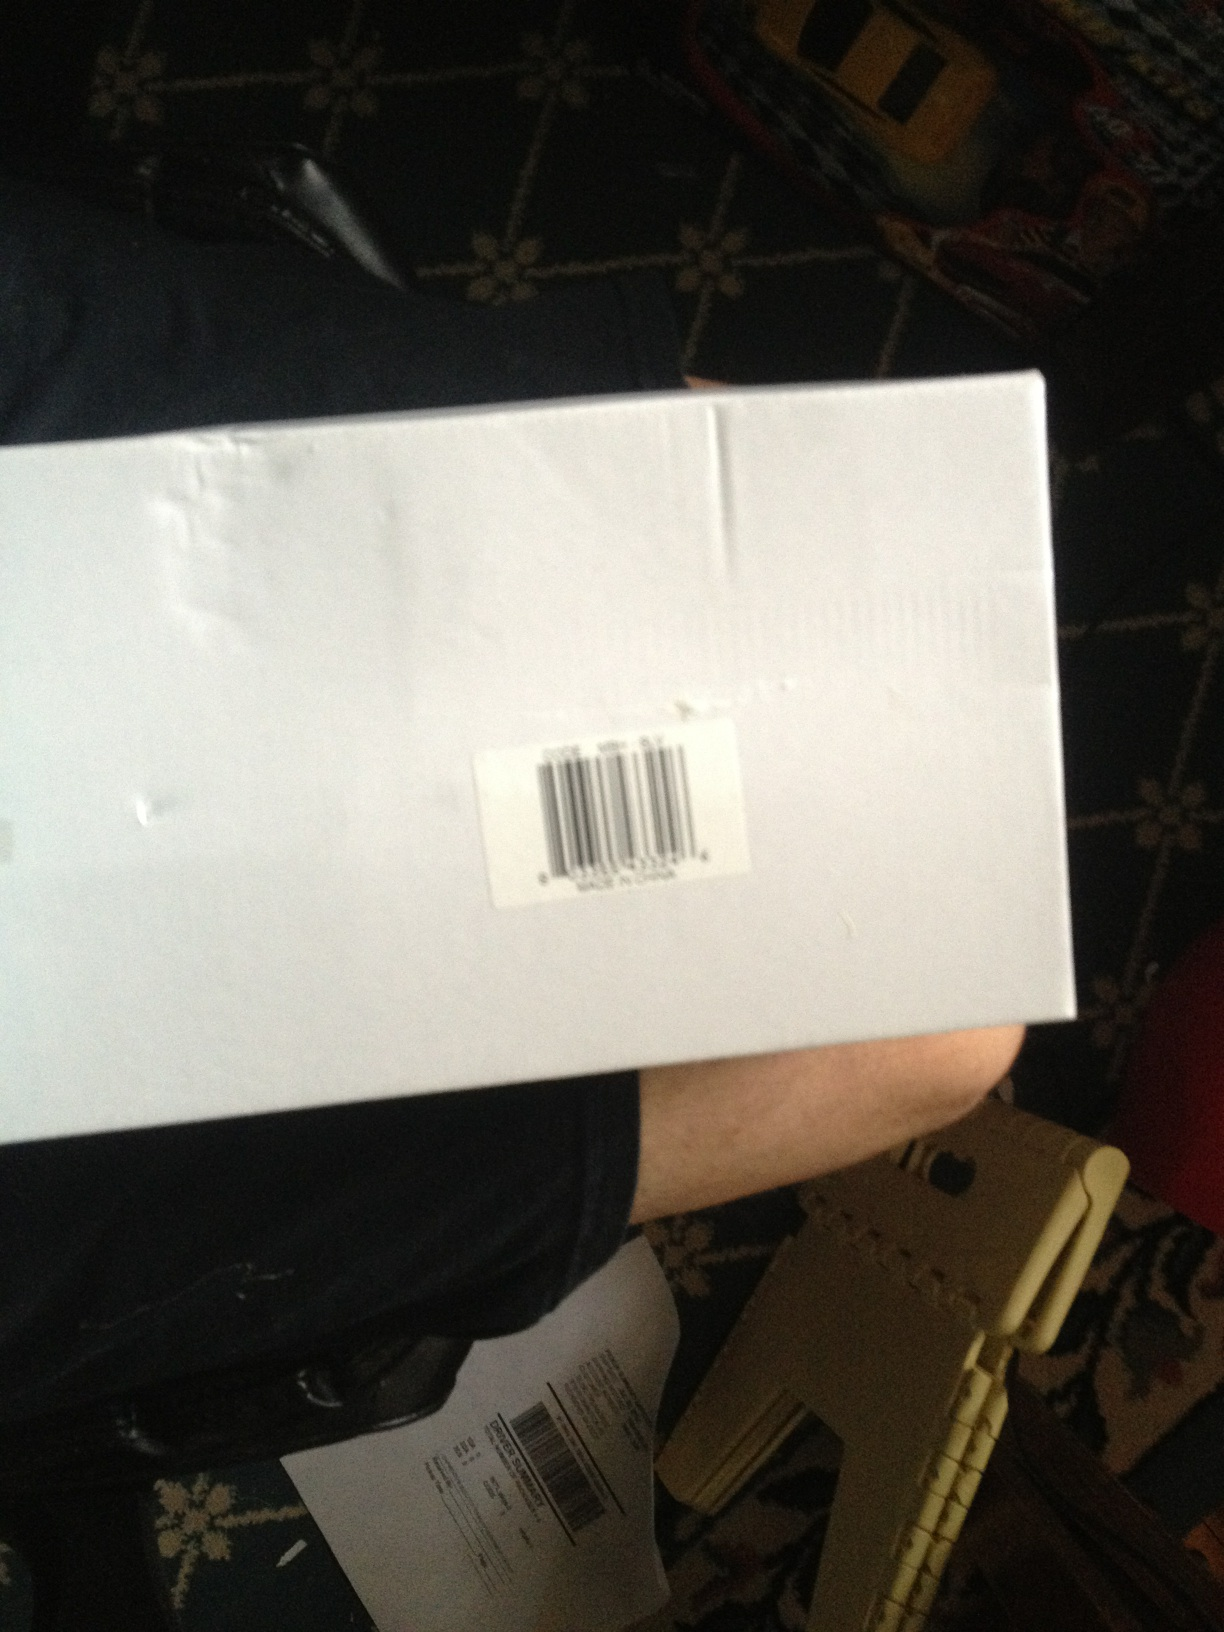Imagine this box has a surprise inside. What could it be? Imagine the box contains a mysterious gadget that hasn't hit the market yet. Inside, carefully packed, is a sleek device with futuristic design hinted from the elegant packaging materials. Alongside the gadget, there's a letter hinting at an incredible opportunity to be the first to test it and provide feedback to the creators. 